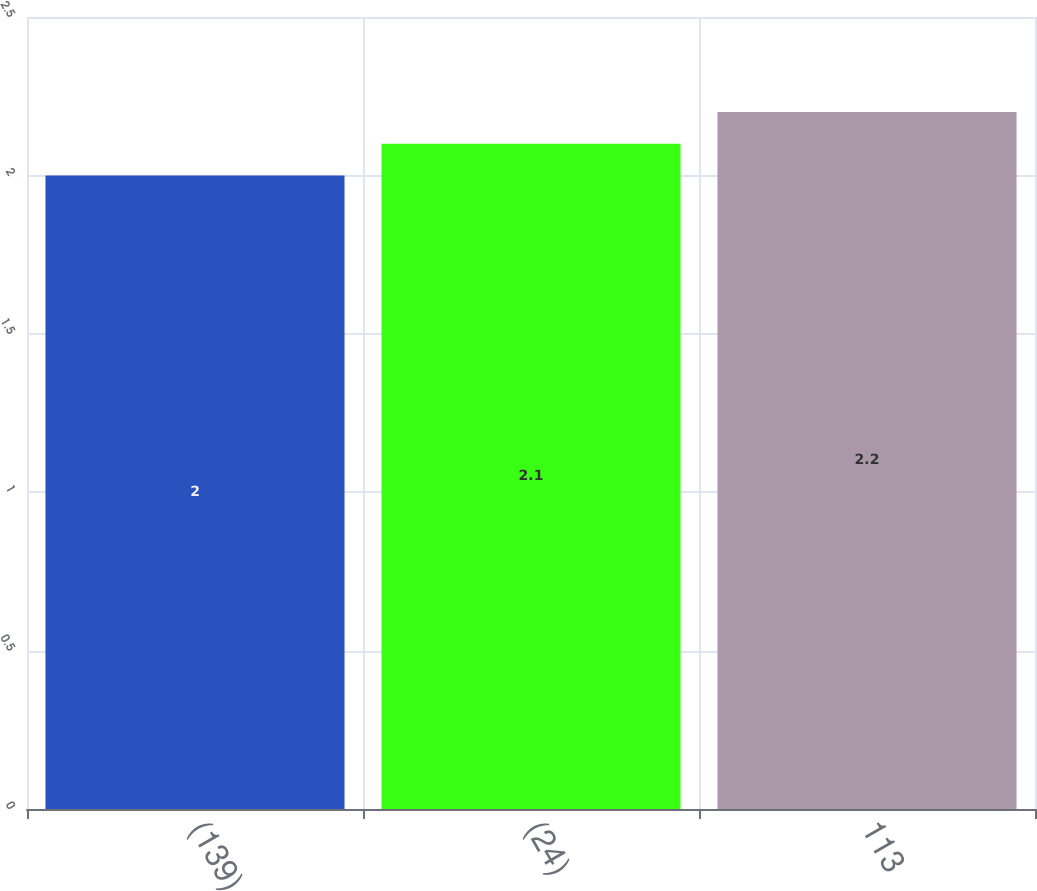<chart> <loc_0><loc_0><loc_500><loc_500><bar_chart><fcel>(139)<fcel>(24)<fcel>113<nl><fcel>2<fcel>2.1<fcel>2.2<nl></chart> 